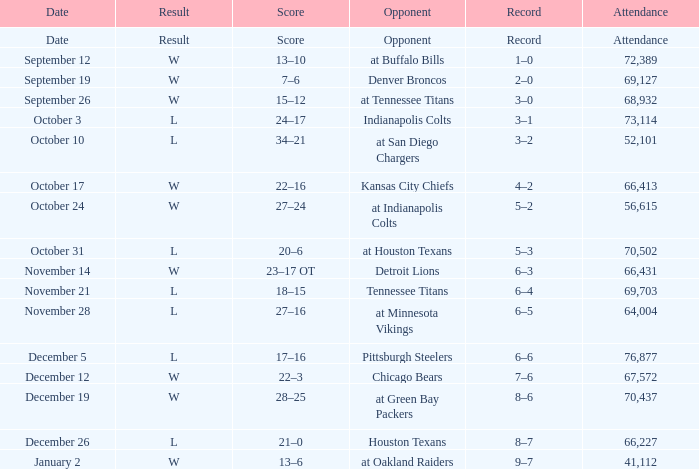What score has houston texans as the opponent? 21–0. 